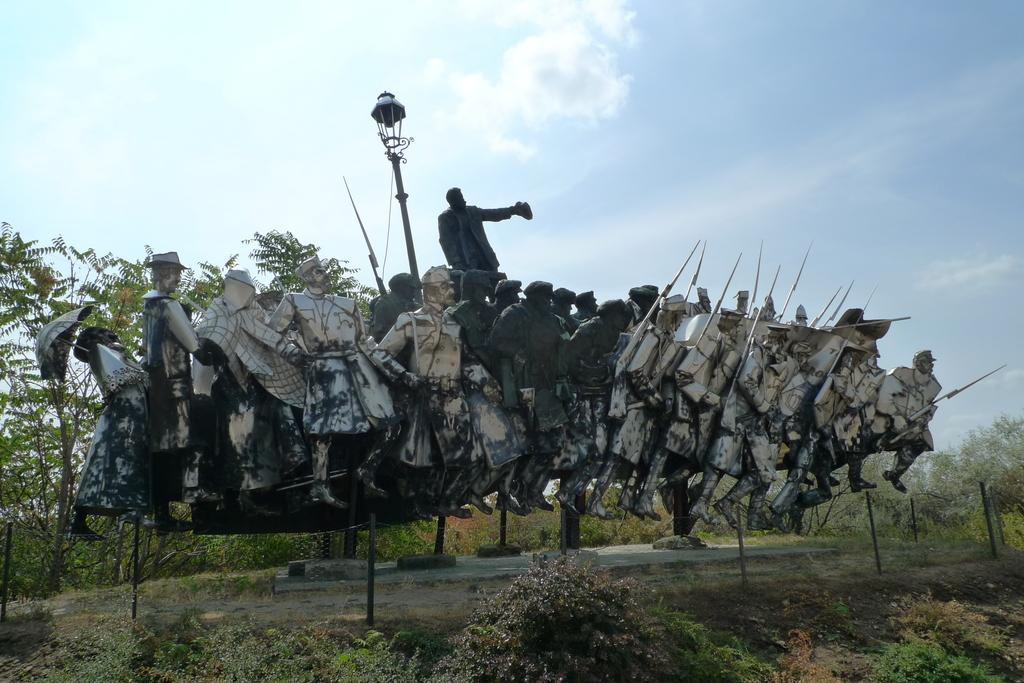What type of objects are depicted as sculptures in the image? There are sculptures of people in the image. What other elements can be seen in the image besides the sculptures? There are plants and a light on a pole in the image. What is visible in the background of the image? The background of the image includes trees and the sky. What type of blade can be seen cutting through the sculptures in the image? There is no blade present in the image, and the sculptures are not being cut. 